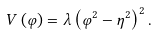Convert formula to latex. <formula><loc_0><loc_0><loc_500><loc_500>V \left ( \varphi \right ) = \lambda \left ( \varphi ^ { 2 } - \eta ^ { 2 } \right ) ^ { 2 } .</formula> 